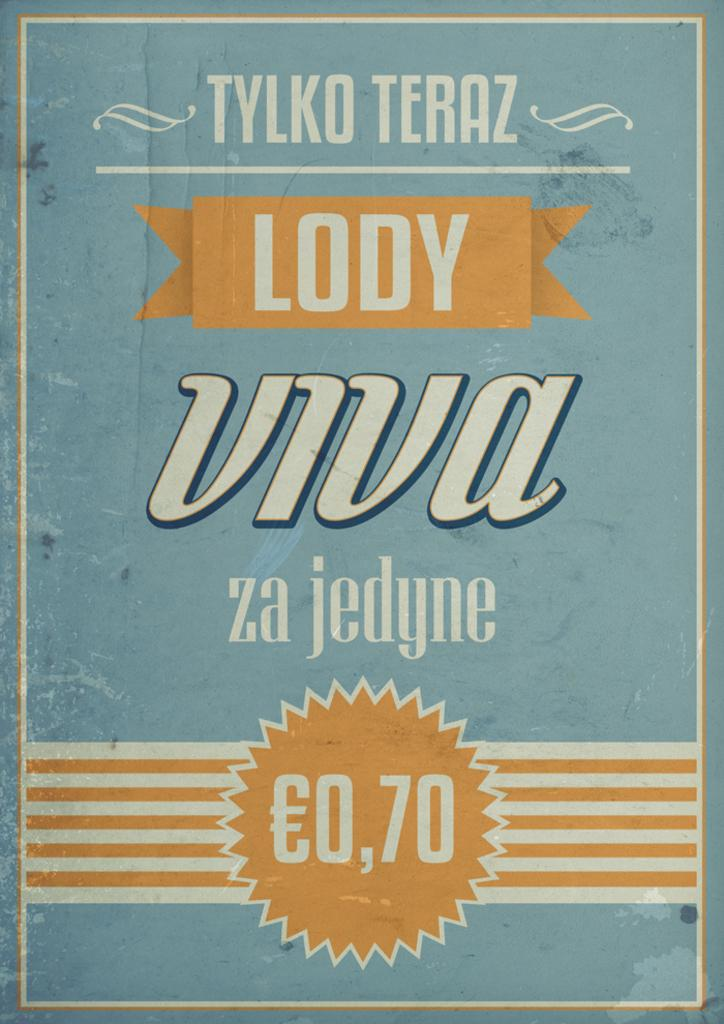What can be seen in the image that conveys information or a message? There is text presented in the image. What type of silk is being used by the hen in the image? There is no hen or silk present in the image; it only contains text. Can you describe the swimming technique of the person in the image? There is no person swimming in the image; it only contains text. 